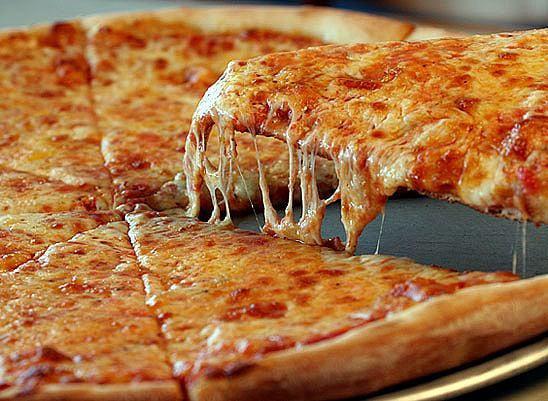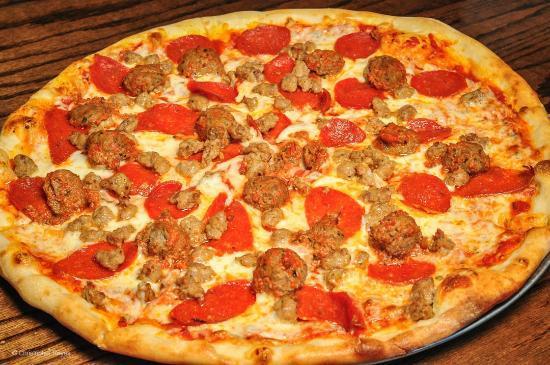The first image is the image on the left, the second image is the image on the right. Evaluate the accuracy of this statement regarding the images: "There are two pizzas with one still in a cardboard box.". Is it true? Answer yes or no. No. The first image is the image on the left, the second image is the image on the right. For the images shown, is this caption "The pizza in the image on the left is sitting in a cardboard box." true? Answer yes or no. No. 